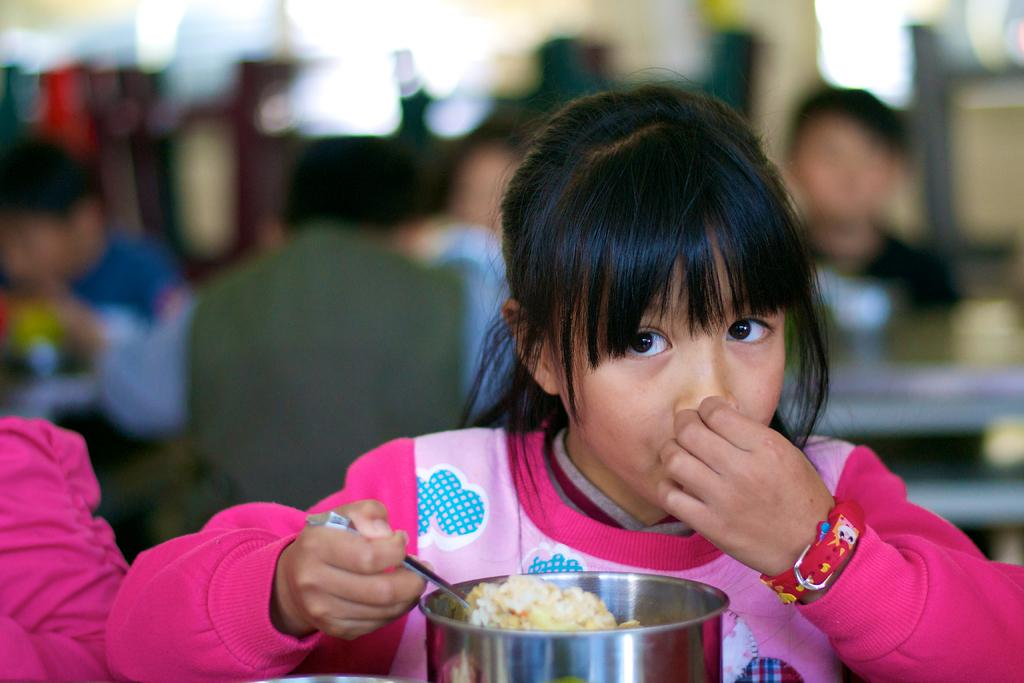Who is the main subject in the picture? There is a small girl in the picture. What is the girl wearing? The girl is wearing a pink top. What is the girl doing in the picture? The girl is sitting and eating food from a silver box. Can you describe the background of the image? The background of the image is blurred. What type of patch can be seen on the girl's pants in the image? There is no patch visible on the girl's pants in the image. How many leaves are on the tree in the background of the image? There is no tree or leaves present in the image, as the background is blurred. 